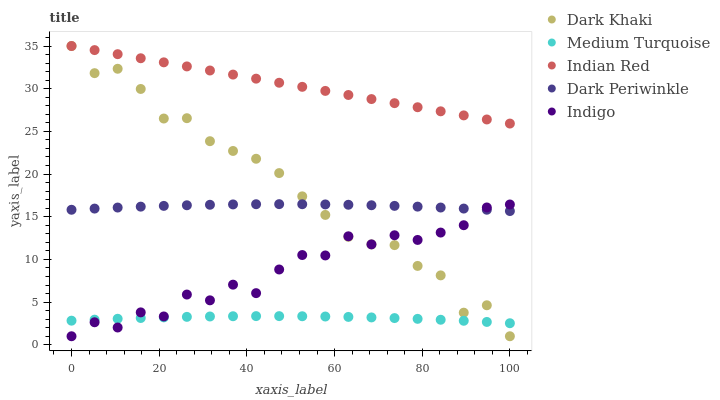Does Medium Turquoise have the minimum area under the curve?
Answer yes or no. Yes. Does Indian Red have the maximum area under the curve?
Answer yes or no. Yes. Does Indigo have the minimum area under the curve?
Answer yes or no. No. Does Indigo have the maximum area under the curve?
Answer yes or no. No. Is Indian Red the smoothest?
Answer yes or no. Yes. Is Indigo the roughest?
Answer yes or no. Yes. Is Indigo the smoothest?
Answer yes or no. No. Is Indian Red the roughest?
Answer yes or no. No. Does Dark Khaki have the lowest value?
Answer yes or no. Yes. Does Indian Red have the lowest value?
Answer yes or no. No. Does Indian Red have the highest value?
Answer yes or no. Yes. Does Indigo have the highest value?
Answer yes or no. No. Is Dark Periwinkle less than Indian Red?
Answer yes or no. Yes. Is Indian Red greater than Indigo?
Answer yes or no. Yes. Does Indigo intersect Medium Turquoise?
Answer yes or no. Yes. Is Indigo less than Medium Turquoise?
Answer yes or no. No. Is Indigo greater than Medium Turquoise?
Answer yes or no. No. Does Dark Periwinkle intersect Indian Red?
Answer yes or no. No. 